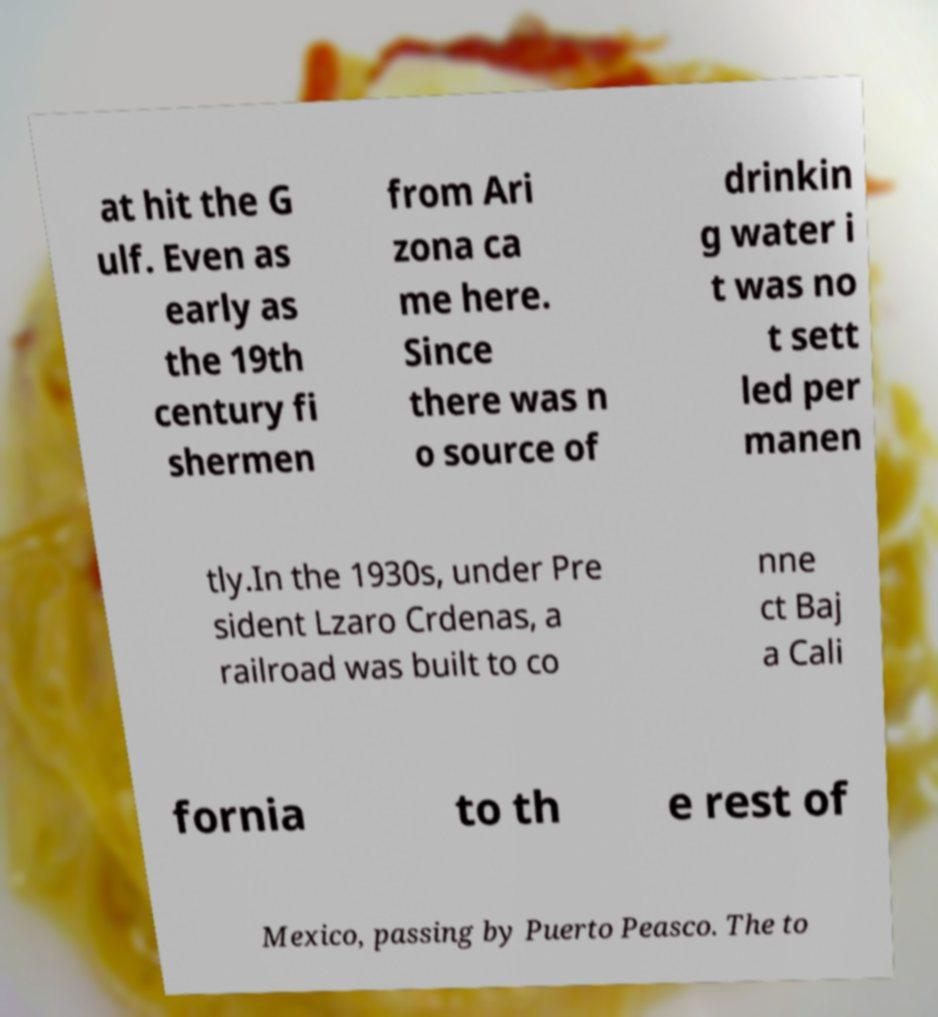Could you extract and type out the text from this image? at hit the G ulf. Even as early as the 19th century fi shermen from Ari zona ca me here. Since there was n o source of drinkin g water i t was no t sett led per manen tly.In the 1930s, under Pre sident Lzaro Crdenas, a railroad was built to co nne ct Baj a Cali fornia to th e rest of Mexico, passing by Puerto Peasco. The to 